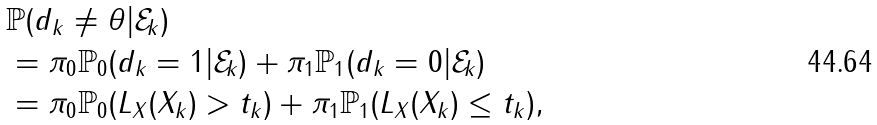<formula> <loc_0><loc_0><loc_500><loc_500>& \mathbb { P } ( d _ { k } \neq \theta | \mathcal { E } _ { k } ) \\ & = \pi _ { 0 } \mathbb { P } _ { 0 } ( d _ { k } = 1 | \mathcal { E } _ { k } ) + \pi _ { 1 } \mathbb { P } _ { 1 } ( d _ { k } = 0 | \mathcal { E } _ { k } ) \\ & = \pi _ { 0 } \mathbb { P } _ { 0 } ( L _ { X } ( X _ { k } ) > t _ { k } ) + \pi _ { 1 } \mathbb { P } _ { 1 } ( L _ { X } ( X _ { k } ) \leq t _ { k } ) ,</formula> 